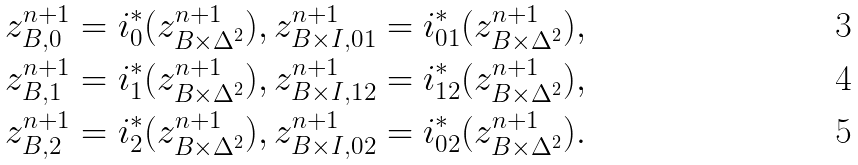<formula> <loc_0><loc_0><loc_500><loc_500>z ^ { n + 1 } _ { B , 0 } = i ^ { * } _ { 0 } ( z ^ { n + 1 } _ { B \times \Delta ^ { 2 } } ) , \, & z ^ { n + 1 } _ { B \times I , 0 1 } = i ^ { * } _ { 0 1 } ( z ^ { n + 1 } _ { B \times \Delta ^ { 2 } } ) , \\ z ^ { n + 1 } _ { B , 1 } = i ^ { * } _ { 1 } ( z ^ { n + 1 } _ { B \times \Delta ^ { 2 } } ) , \, & z ^ { n + 1 } _ { B \times I , 1 2 } = i ^ { * } _ { 1 2 } ( z ^ { n + 1 } _ { B \times \Delta ^ { 2 } } ) , \\ z ^ { n + 1 } _ { B , 2 } = i ^ { * } _ { 2 } ( z ^ { n + 1 } _ { B \times \Delta ^ { 2 } } ) , \, & z ^ { n + 1 } _ { B \times I , 0 2 } = i ^ { * } _ { 0 2 } ( z ^ { n + 1 } _ { B \times \Delta ^ { 2 } } ) .</formula> 